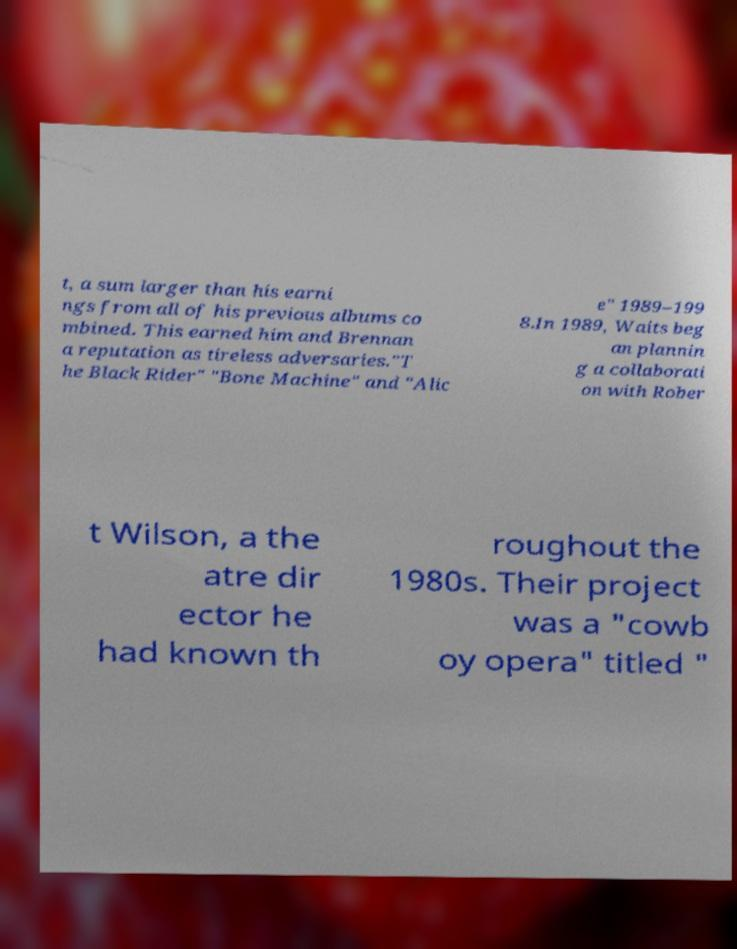I need the written content from this picture converted into text. Can you do that? t, a sum larger than his earni ngs from all of his previous albums co mbined. This earned him and Brennan a reputation as tireless adversaries."T he Black Rider" "Bone Machine" and "Alic e" 1989–199 8.In 1989, Waits beg an plannin g a collaborati on with Rober t Wilson, a the atre dir ector he had known th roughout the 1980s. Their project was a "cowb oy opera" titled " 